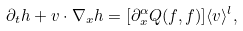Convert formula to latex. <formula><loc_0><loc_0><loc_500><loc_500>\partial _ { t } h + v \cdot \nabla _ { x } h = [ \partial ^ { \alpha } _ { x } Q ( f , f ) ] \langle v \rangle ^ { l } ,</formula> 